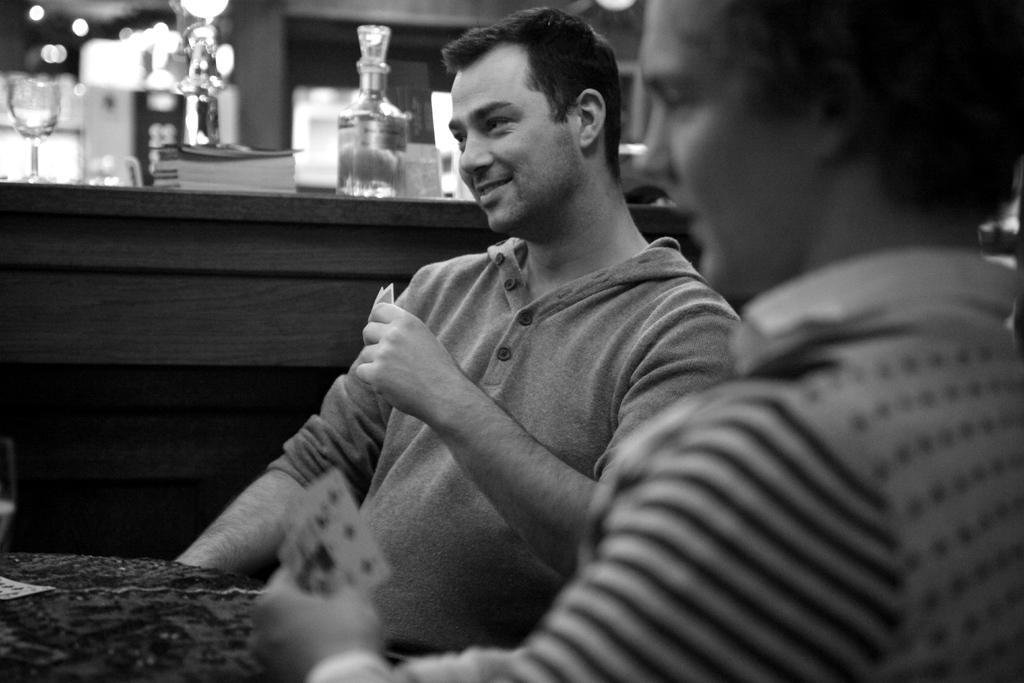Please provide a concise description of this image. A black and white picture. These persons are sitting and holding a cards. On this table there is a card. On this table there is a bottle, book and glass. 